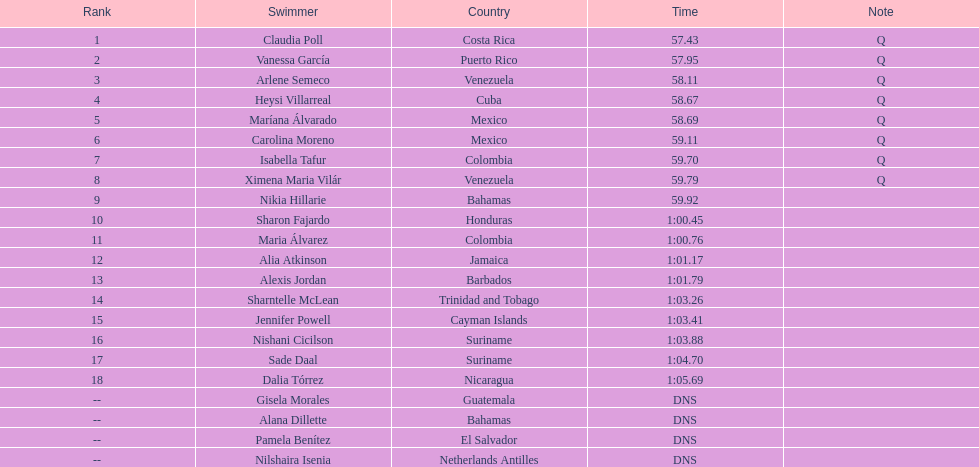How many contestants from venezuela made it to the final? 2. 